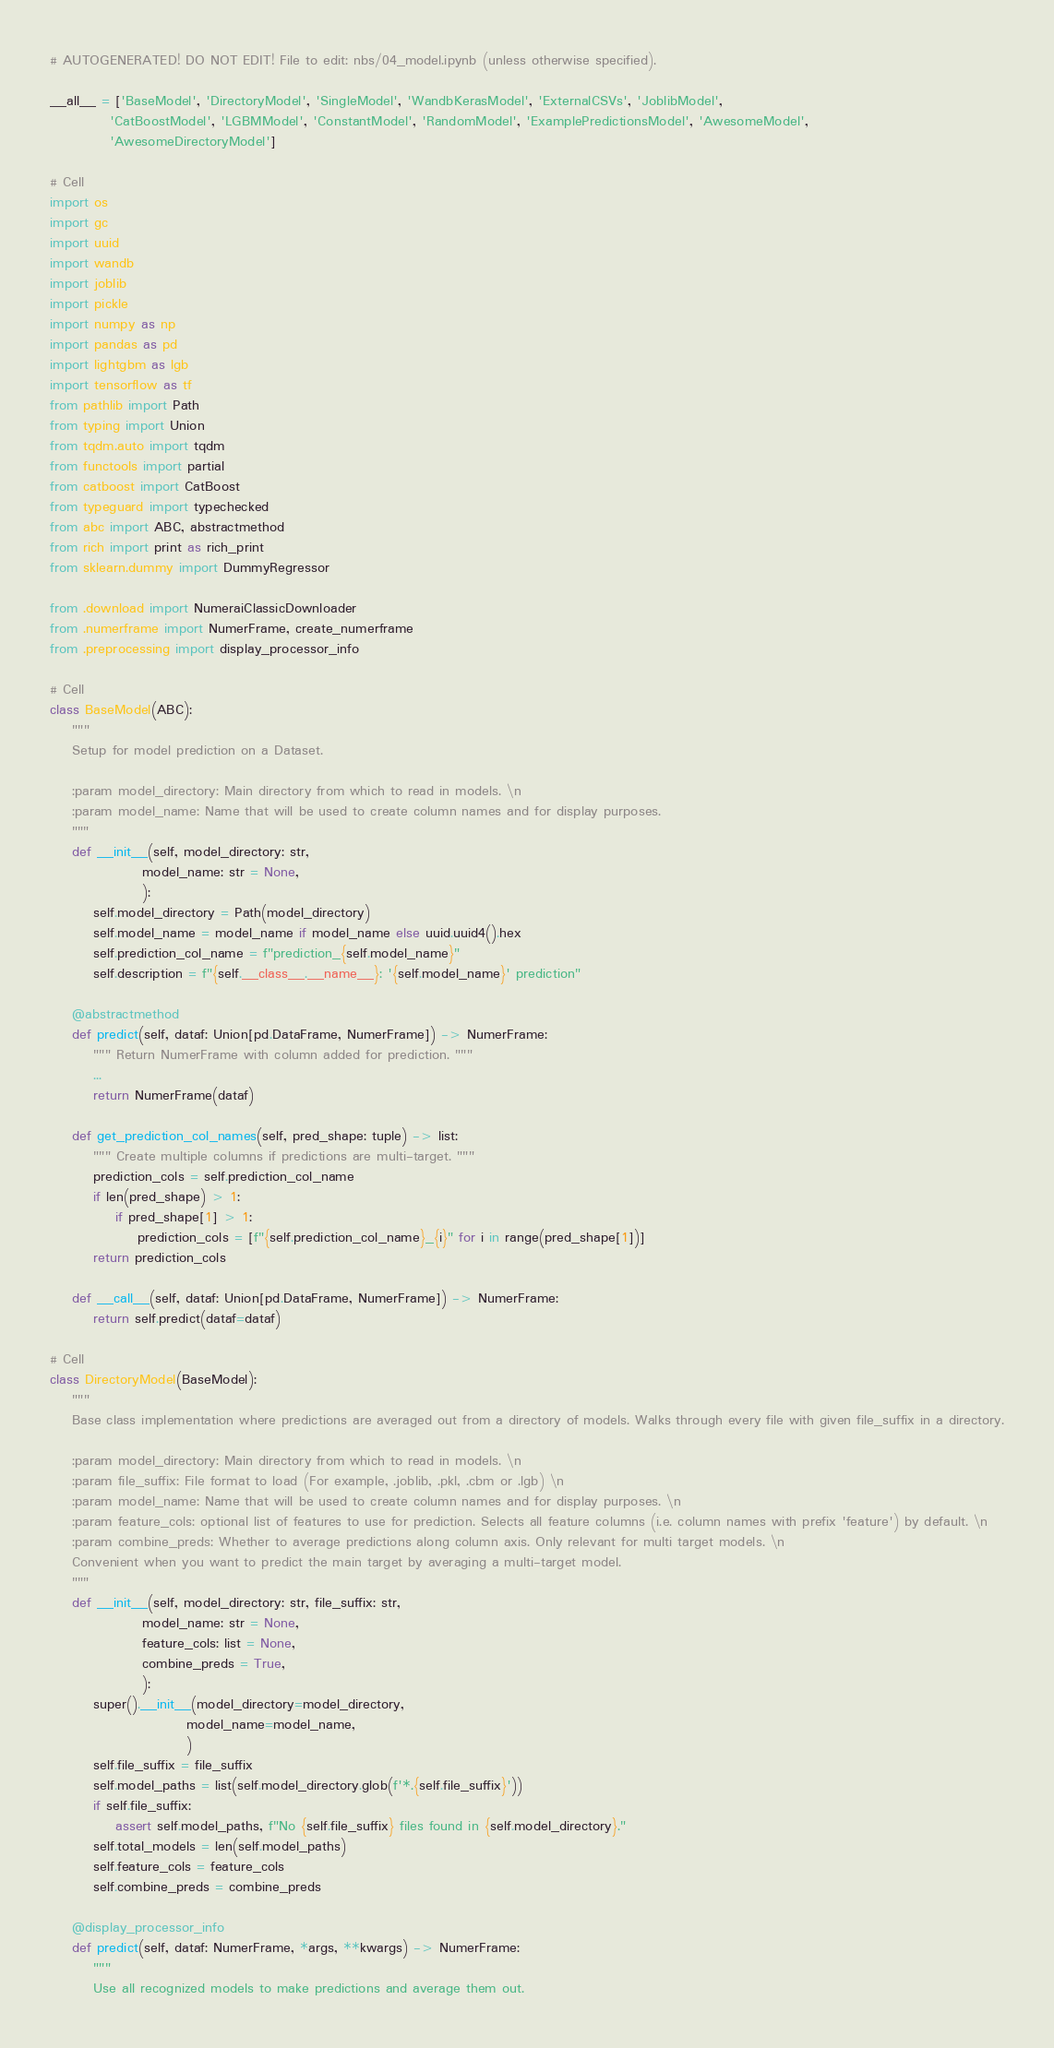<code> <loc_0><loc_0><loc_500><loc_500><_Python_># AUTOGENERATED! DO NOT EDIT! File to edit: nbs/04_model.ipynb (unless otherwise specified).

__all__ = ['BaseModel', 'DirectoryModel', 'SingleModel', 'WandbKerasModel', 'ExternalCSVs', 'JoblibModel',
           'CatBoostModel', 'LGBMModel', 'ConstantModel', 'RandomModel', 'ExamplePredictionsModel', 'AwesomeModel',
           'AwesomeDirectoryModel']

# Cell
import os
import gc
import uuid
import wandb
import joblib
import pickle
import numpy as np
import pandas as pd
import lightgbm as lgb
import tensorflow as tf
from pathlib import Path
from typing import Union
from tqdm.auto import tqdm
from functools import partial
from catboost import CatBoost
from typeguard import typechecked
from abc import ABC, abstractmethod
from rich import print as rich_print
from sklearn.dummy import DummyRegressor

from .download import NumeraiClassicDownloader
from .numerframe import NumerFrame, create_numerframe
from .preprocessing import display_processor_info

# Cell
class BaseModel(ABC):
    """
    Setup for model prediction on a Dataset.

    :param model_directory: Main directory from which to read in models. \n
    :param model_name: Name that will be used to create column names and for display purposes.
    """
    def __init__(self, model_directory: str,
                 model_name: str = None,
                 ):
        self.model_directory = Path(model_directory)
        self.model_name = model_name if model_name else uuid.uuid4().hex
        self.prediction_col_name = f"prediction_{self.model_name}"
        self.description = f"{self.__class__.__name__}: '{self.model_name}' prediction"

    @abstractmethod
    def predict(self, dataf: Union[pd.DataFrame, NumerFrame]) -> NumerFrame:
        """ Return NumerFrame with column added for prediction. """
        ...
        return NumerFrame(dataf)

    def get_prediction_col_names(self, pred_shape: tuple) -> list:
        """ Create multiple columns if predictions are multi-target. """
        prediction_cols = self.prediction_col_name
        if len(pred_shape) > 1:
            if pred_shape[1] > 1:
                prediction_cols = [f"{self.prediction_col_name}_{i}" for i in range(pred_shape[1])]
        return prediction_cols

    def __call__(self, dataf: Union[pd.DataFrame, NumerFrame]) -> NumerFrame:
        return self.predict(dataf=dataf)

# Cell
class DirectoryModel(BaseModel):
    """
    Base class implementation where predictions are averaged out from a directory of models. Walks through every file with given file_suffix in a directory.

    :param model_directory: Main directory from which to read in models. \n
    :param file_suffix: File format to load (For example, .joblib, .pkl, .cbm or .lgb) \n
    :param model_name: Name that will be used to create column names and for display purposes. \n
    :param feature_cols: optional list of features to use for prediction. Selects all feature columns (i.e. column names with prefix 'feature') by default. \n
    :param combine_preds: Whether to average predictions along column axis. Only relevant for multi target models. \n
    Convenient when you want to predict the main target by averaging a multi-target model.
    """
    def __init__(self, model_directory: str, file_suffix: str,
                 model_name: str = None,
                 feature_cols: list = None,
                 combine_preds = True,
                 ):
        super().__init__(model_directory=model_directory,
                         model_name=model_name,
                         )
        self.file_suffix = file_suffix
        self.model_paths = list(self.model_directory.glob(f'*.{self.file_suffix}'))
        if self.file_suffix:
            assert self.model_paths, f"No {self.file_suffix} files found in {self.model_directory}."
        self.total_models = len(self.model_paths)
        self.feature_cols = feature_cols
        self.combine_preds = combine_preds

    @display_processor_info
    def predict(self, dataf: NumerFrame, *args, **kwargs) -> NumerFrame:
        """
        Use all recognized models to make predictions and average them out.</code> 